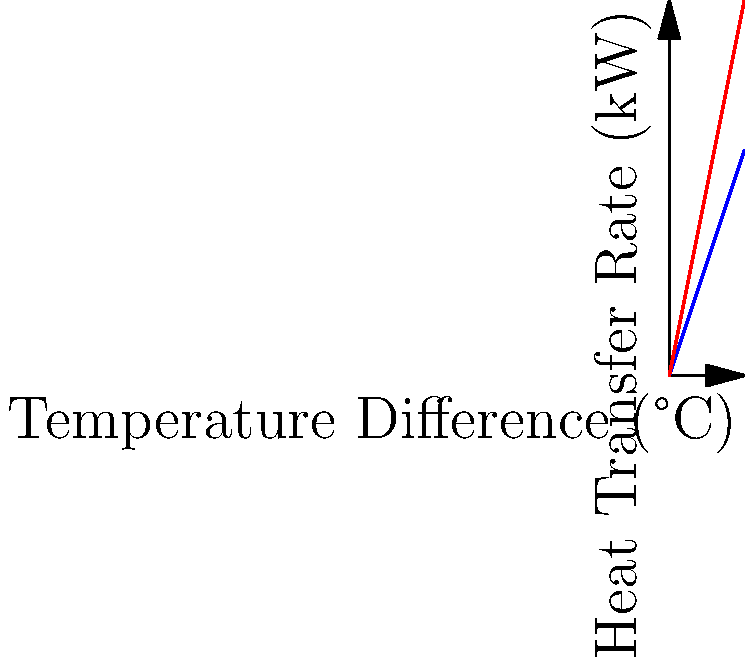As a real estate developer considering the installation of HVAC systems in a large residential complex, you're presented with two options: a standard system and a high-efficiency system. The graph shows the heat transfer rate versus temperature difference for both systems. If the average temperature difference between the indoor and outdoor environment is 8°C, what would be the difference in heat transfer rate (in kW) between the high-efficiency and standard systems? To solve this problem, we'll follow these steps:

1. Identify the equations for heat transfer rate for both systems:
   - Standard System: $Q_s = 3 \Delta T$
   - High-Efficiency System: $Q_h = 5 \Delta T$
   where $Q$ is the heat transfer rate in kW and $\Delta T$ is the temperature difference in °C.

2. Calculate the heat transfer rate for the standard system at $\Delta T = 8°C$:
   $Q_s = 3 \times 8 = 24$ kW

3. Calculate the heat transfer rate for the high-efficiency system at $\Delta T = 8°C$:
   $Q_h = 5 \times 8 = 40$ kW

4. Find the difference between the two systems:
   $\Delta Q = Q_h - Q_s = 40 - 24 = 16$ kW

This 16 kW difference represents the increased heat transfer capability of the high-efficiency system compared to the standard system at the given temperature difference.
Answer: 16 kW 